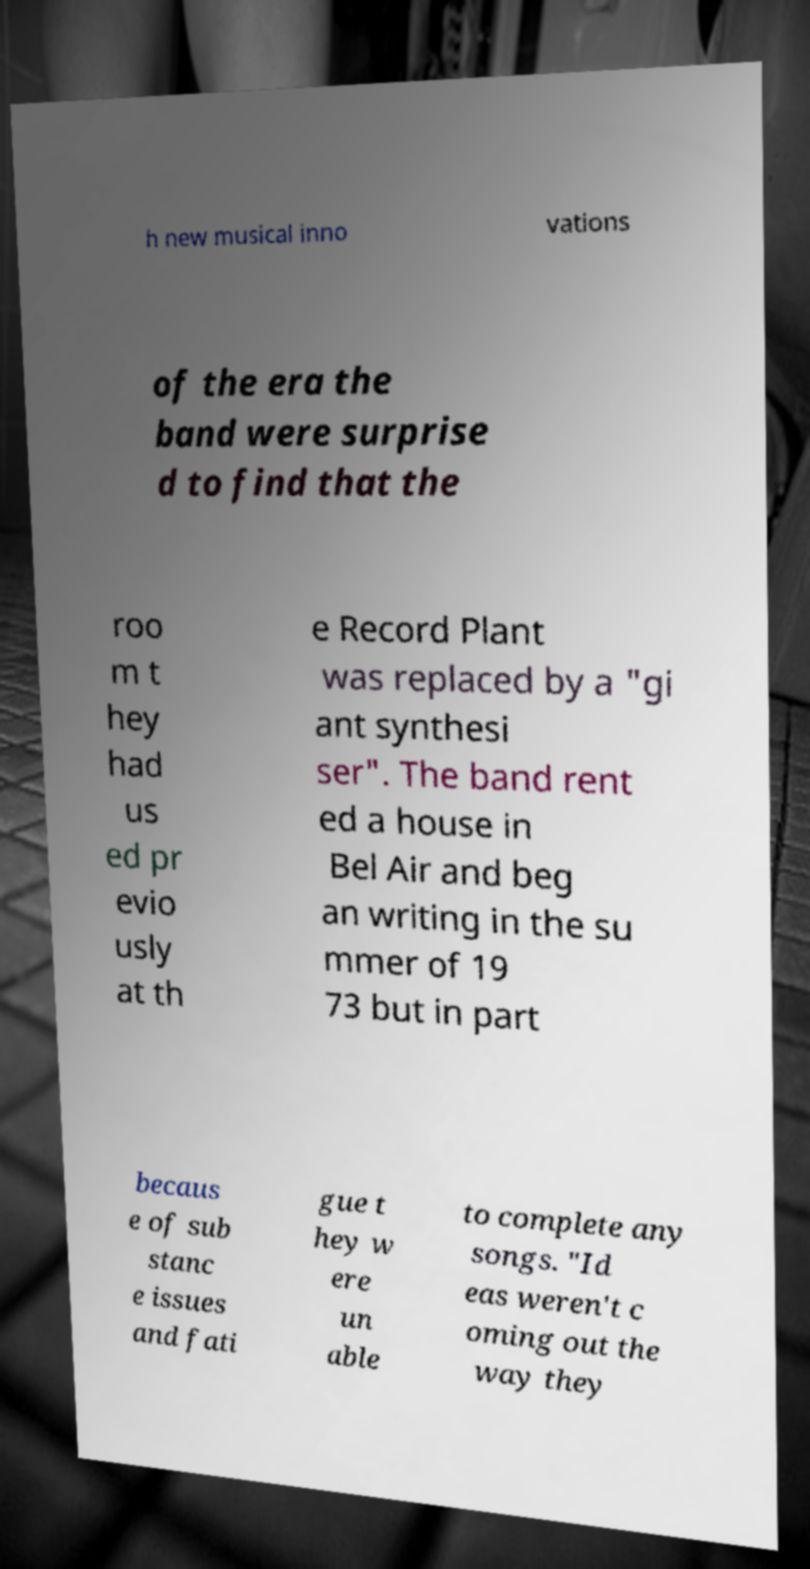What messages or text are displayed in this image? I need them in a readable, typed format. h new musical inno vations of the era the band were surprise d to find that the roo m t hey had us ed pr evio usly at th e Record Plant was replaced by a "gi ant synthesi ser". The band rent ed a house in Bel Air and beg an writing in the su mmer of 19 73 but in part becaus e of sub stanc e issues and fati gue t hey w ere un able to complete any songs. "Id eas weren't c oming out the way they 